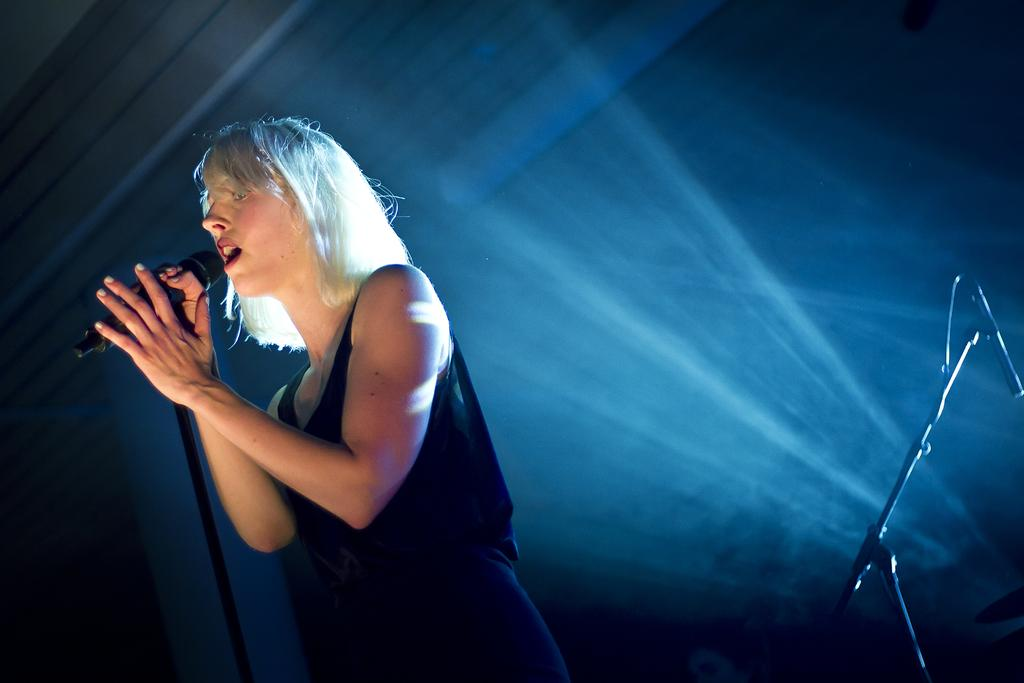Who is the main subject in the image? There is a woman in the image. What is the woman doing in the image? The woman is singing in the image. What tool is the woman using while singing? The woman is using a microphone in the image. What type of notebook is the woman using in the image? There is no notebook present in the image. Where is the cave located in the image? There is no cave present in the image. 